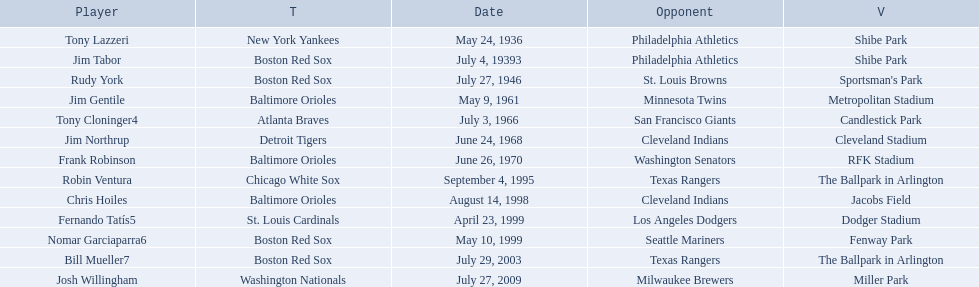Who are the opponents of the boston red sox during baseball home run records? Philadelphia Athletics, St. Louis Browns, Seattle Mariners, Texas Rangers. Of those which was the opponent on july 27, 1946? St. Louis Browns. 